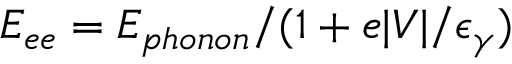<formula> <loc_0><loc_0><loc_500><loc_500>E _ { e e } = E _ { p h o n o n } / ( 1 + e | V | / \epsilon _ { \gamma } )</formula> 